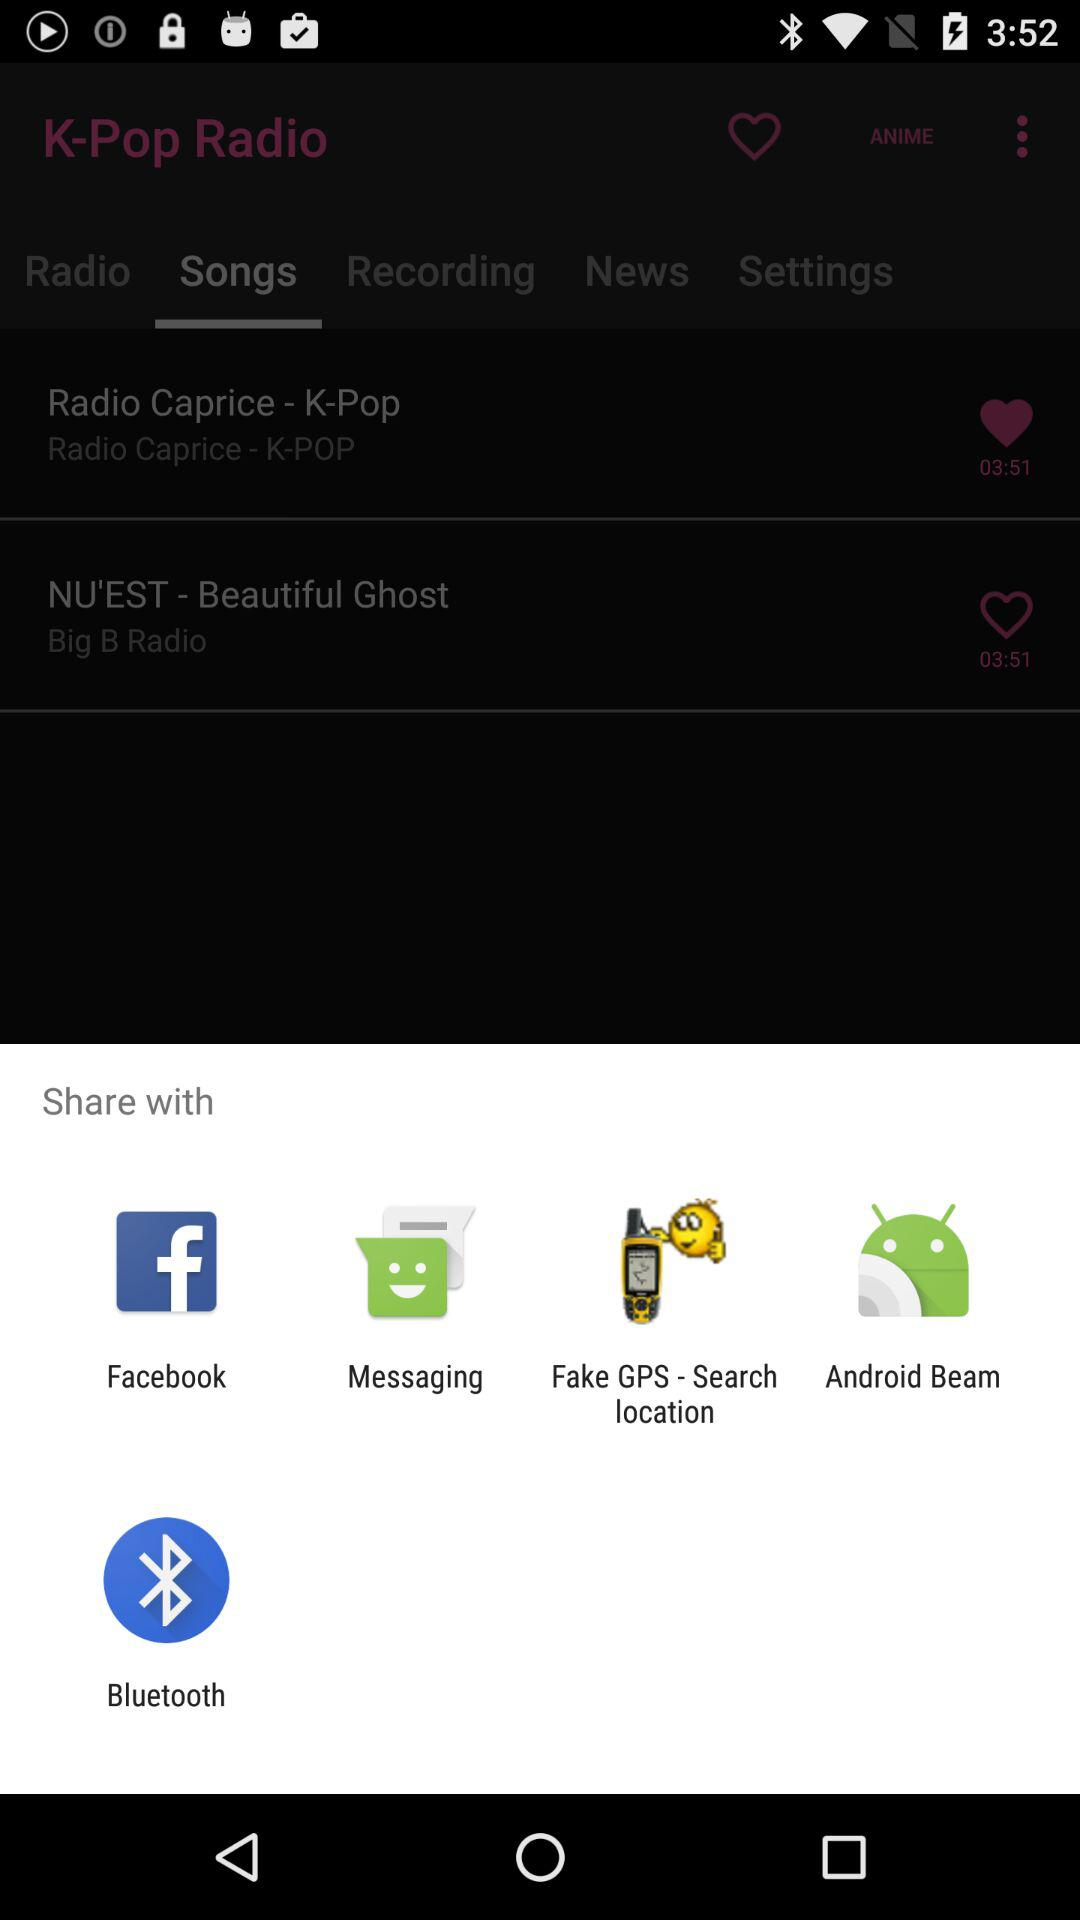What are the apps that can be used to share the content? The apps that can be used to share the content are "Facebook", "Messaging", "Fake GPS - Search location", "Android Beam", and "Bluetooth". 